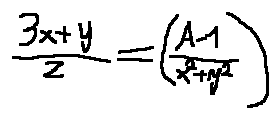Convert formula to latex. <formula><loc_0><loc_0><loc_500><loc_500>\frac { 3 x + y } { z } = ( \frac { A - 1 } { x ^ { 2 } + y ^ { 2 } } )</formula> 